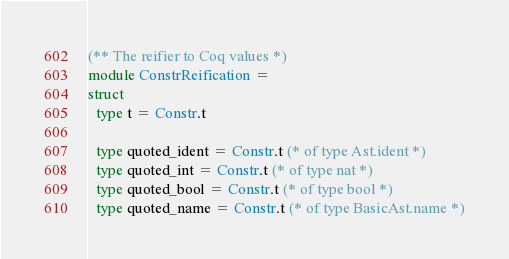<code> <loc_0><loc_0><loc_500><loc_500><_OCaml_>
(** The reifier to Coq values *)
module ConstrReification =
struct
  type t = Constr.t

  type quoted_ident = Constr.t (* of type Ast.ident *)
  type quoted_int = Constr.t (* of type nat *)
  type quoted_bool = Constr.t (* of type bool *)
  type quoted_name = Constr.t (* of type BasicAst.name *)</code> 